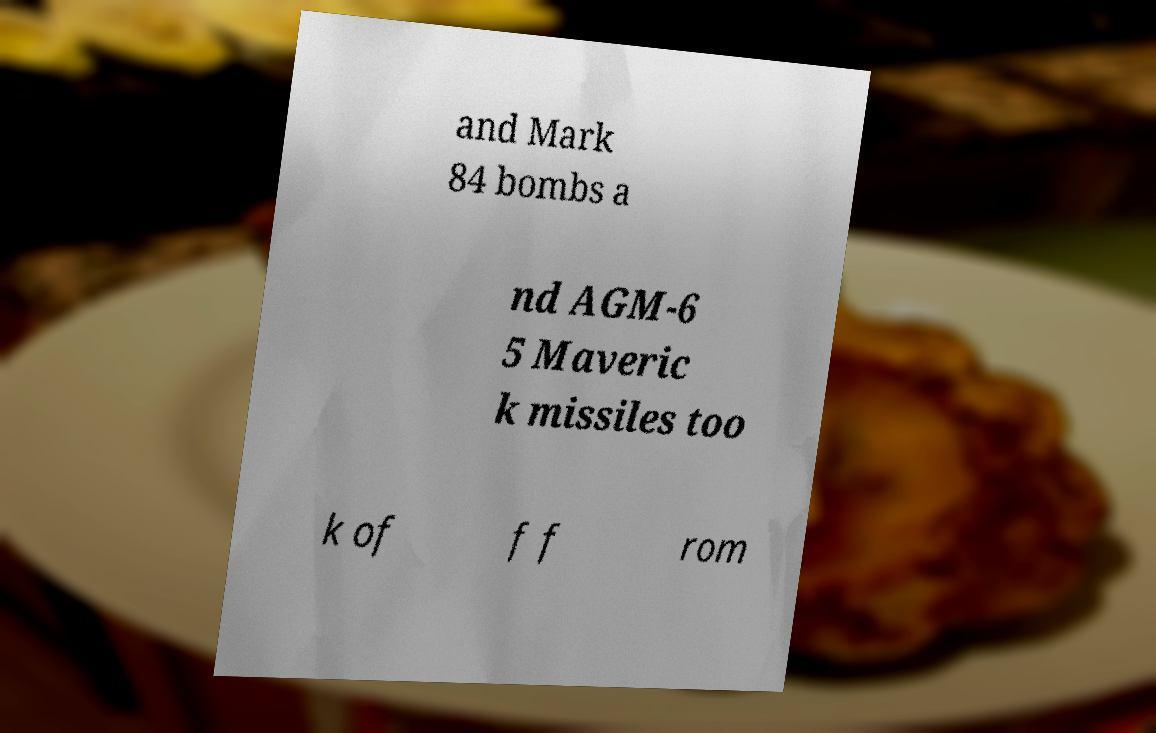For documentation purposes, I need the text within this image transcribed. Could you provide that? and Mark 84 bombs a nd AGM-6 5 Maveric k missiles too k of f f rom 